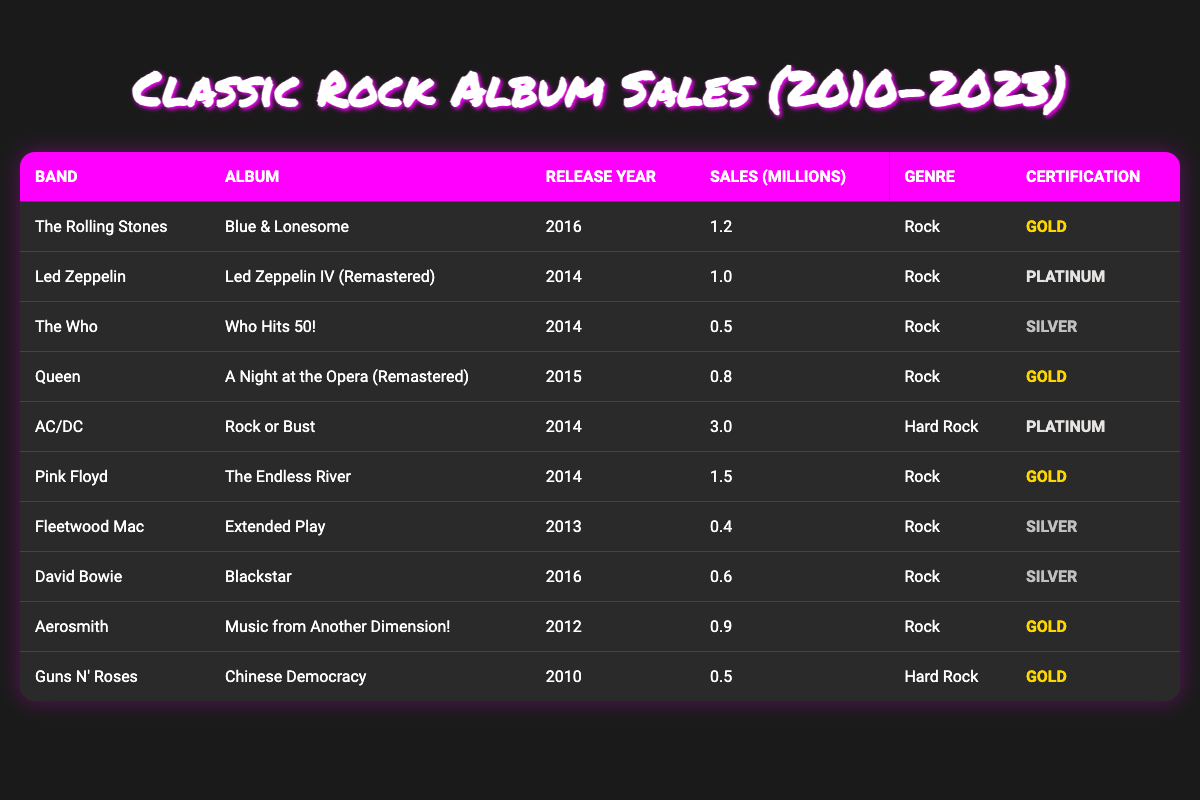What is the album with the highest sales? The album "Rock or Bust" by AC/DC has the highest sales of 3.0 million.
Answer: Rock or Bust Which band's album was released in 2016? "Blue & Lonesome" by The Rolling Stones and "Blackstar" by David Bowie were both released in 2016.
Answer: The Rolling Stones, David Bowie What is the total sales of albums certified Gold? The Gold certified albums have sales of (1.2 + 0.8 + 1.5 + 0.9 + 0.5) = 4.9 million.
Answer: 4.9 million Which album has the lowest sales? The album "Extended Play" by Fleetwood Mac has the lowest sales of 0.4 million.
Answer: Extended Play Has any album been certified Platinum? Yes, "Led Zeppelin IV (Remastered)" by Led Zeppelin and "Rock or Bust" by AC/DC have been certified Platinum.
Answer: Yes What is the average sales of all albums listed in the table? The total sales are (1.2 + 1.0 + 0.5 + 0.8 + 3.0 + 1.5 + 0.4 + 0.6 + 0.9 + 0.5) = 10.4 million. There are 10 albums, so the average is 10.4/10 = 1.04 million.
Answer: 1.04 million Which band has the most albums listed in the table? The data provides one album per band, so no band has more than one album listed.
Answer: No band has multiple albums What percentage of albums are certified Silver? There are 3 Silver certified albums out of 10 total albums. The percentage is (3/10) * 100 = 30%.
Answer: 30% Which genre has the highest sales? The genre "Hard Rock" has sales of 3.0 million from AC/DC, while all Rock albums combined sell 7.4 million. Therefore, Rock has the highest sales.
Answer: Rock How many albums have been released after 2014? The albums "Blue & Lonesome," "Blackstar," and "Extended Play" have been released after 2014, totaling 3 albums.
Answer: 3 albums Which album has the same sales as "Chinese Democracy"? "Who Hits 50!" by The Who has sales of 0.5 million, the same as "Chinese Democracy" by Guns N' Roses.
Answer: Who Hits 50! 